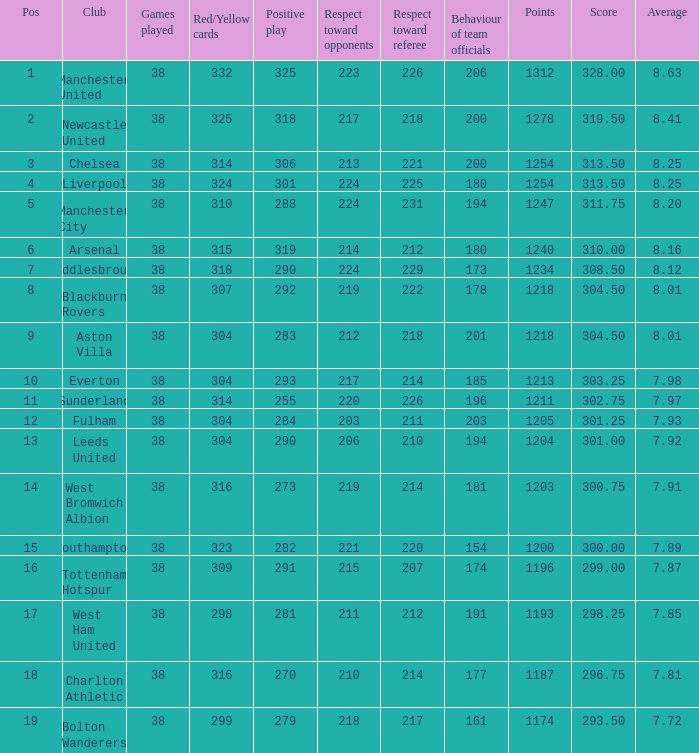What is the post for west ham united? 17.0. 